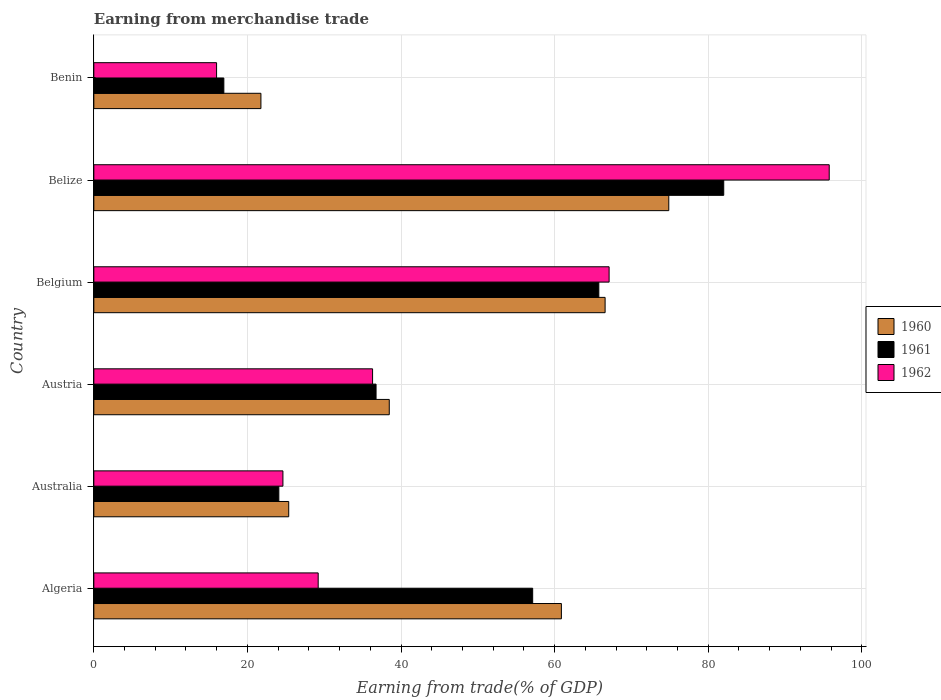How many different coloured bars are there?
Provide a succinct answer. 3. How many groups of bars are there?
Give a very brief answer. 6. Are the number of bars per tick equal to the number of legend labels?
Give a very brief answer. Yes. Are the number of bars on each tick of the Y-axis equal?
Keep it short and to the point. Yes. How many bars are there on the 4th tick from the bottom?
Your response must be concise. 3. What is the label of the 3rd group of bars from the top?
Your answer should be very brief. Belgium. What is the earnings from trade in 1960 in Algeria?
Ensure brevity in your answer.  60.88. Across all countries, what is the maximum earnings from trade in 1962?
Make the answer very short. 95.76. Across all countries, what is the minimum earnings from trade in 1960?
Offer a terse response. 21.76. In which country was the earnings from trade in 1960 maximum?
Keep it short and to the point. Belize. In which country was the earnings from trade in 1962 minimum?
Make the answer very short. Benin. What is the total earnings from trade in 1962 in the graph?
Your answer should be very brief. 268.98. What is the difference between the earnings from trade in 1962 in Australia and that in Benin?
Provide a succinct answer. 8.64. What is the difference between the earnings from trade in 1962 in Algeria and the earnings from trade in 1960 in Belgium?
Keep it short and to the point. -37.36. What is the average earnings from trade in 1962 per country?
Offer a terse response. 44.83. What is the difference between the earnings from trade in 1961 and earnings from trade in 1960 in Belize?
Offer a terse response. 7.15. What is the ratio of the earnings from trade in 1962 in Australia to that in Austria?
Give a very brief answer. 0.68. Is the difference between the earnings from trade in 1961 in Australia and Belgium greater than the difference between the earnings from trade in 1960 in Australia and Belgium?
Your response must be concise. No. What is the difference between the highest and the second highest earnings from trade in 1962?
Provide a succinct answer. 28.66. What is the difference between the highest and the lowest earnings from trade in 1962?
Your answer should be compact. 79.77. In how many countries, is the earnings from trade in 1960 greater than the average earnings from trade in 1960 taken over all countries?
Provide a succinct answer. 3. What does the 1st bar from the top in Austria represents?
Make the answer very short. 1962. Is it the case that in every country, the sum of the earnings from trade in 1961 and earnings from trade in 1962 is greater than the earnings from trade in 1960?
Provide a short and direct response. Yes. Are the values on the major ticks of X-axis written in scientific E-notation?
Ensure brevity in your answer.  No. How many legend labels are there?
Offer a very short reply. 3. What is the title of the graph?
Provide a short and direct response. Earning from merchandise trade. Does "2007" appear as one of the legend labels in the graph?
Give a very brief answer. No. What is the label or title of the X-axis?
Your answer should be very brief. Earning from trade(% of GDP). What is the Earning from trade(% of GDP) in 1960 in Algeria?
Your answer should be very brief. 60.88. What is the Earning from trade(% of GDP) of 1961 in Algeria?
Your answer should be compact. 57.14. What is the Earning from trade(% of GDP) in 1962 in Algeria?
Your answer should be very brief. 29.22. What is the Earning from trade(% of GDP) in 1960 in Australia?
Your answer should be very brief. 25.38. What is the Earning from trade(% of GDP) in 1961 in Australia?
Provide a succinct answer. 24.09. What is the Earning from trade(% of GDP) in 1962 in Australia?
Provide a succinct answer. 24.62. What is the Earning from trade(% of GDP) in 1960 in Austria?
Provide a succinct answer. 38.47. What is the Earning from trade(% of GDP) in 1961 in Austria?
Keep it short and to the point. 36.75. What is the Earning from trade(% of GDP) in 1962 in Austria?
Make the answer very short. 36.3. What is the Earning from trade(% of GDP) of 1960 in Belgium?
Offer a very short reply. 66.58. What is the Earning from trade(% of GDP) in 1961 in Belgium?
Keep it short and to the point. 65.76. What is the Earning from trade(% of GDP) of 1962 in Belgium?
Offer a terse response. 67.1. What is the Earning from trade(% of GDP) in 1960 in Belize?
Your answer should be compact. 74.87. What is the Earning from trade(% of GDP) of 1961 in Belize?
Provide a short and direct response. 82.02. What is the Earning from trade(% of GDP) in 1962 in Belize?
Provide a succinct answer. 95.76. What is the Earning from trade(% of GDP) in 1960 in Benin?
Your response must be concise. 21.76. What is the Earning from trade(% of GDP) in 1961 in Benin?
Provide a succinct answer. 16.93. What is the Earning from trade(% of GDP) in 1962 in Benin?
Keep it short and to the point. 15.99. Across all countries, what is the maximum Earning from trade(% of GDP) of 1960?
Keep it short and to the point. 74.87. Across all countries, what is the maximum Earning from trade(% of GDP) in 1961?
Make the answer very short. 82.02. Across all countries, what is the maximum Earning from trade(% of GDP) in 1962?
Keep it short and to the point. 95.76. Across all countries, what is the minimum Earning from trade(% of GDP) in 1960?
Give a very brief answer. 21.76. Across all countries, what is the minimum Earning from trade(% of GDP) in 1961?
Offer a very short reply. 16.93. Across all countries, what is the minimum Earning from trade(% of GDP) of 1962?
Your response must be concise. 15.99. What is the total Earning from trade(% of GDP) of 1960 in the graph?
Provide a succinct answer. 287.94. What is the total Earning from trade(% of GDP) of 1961 in the graph?
Provide a short and direct response. 282.7. What is the total Earning from trade(% of GDP) of 1962 in the graph?
Give a very brief answer. 268.98. What is the difference between the Earning from trade(% of GDP) in 1960 in Algeria and that in Australia?
Offer a terse response. 35.51. What is the difference between the Earning from trade(% of GDP) in 1961 in Algeria and that in Australia?
Provide a short and direct response. 33.05. What is the difference between the Earning from trade(% of GDP) in 1962 in Algeria and that in Australia?
Your answer should be very brief. 4.59. What is the difference between the Earning from trade(% of GDP) of 1960 in Algeria and that in Austria?
Offer a terse response. 22.41. What is the difference between the Earning from trade(% of GDP) in 1961 in Algeria and that in Austria?
Provide a short and direct response. 20.39. What is the difference between the Earning from trade(% of GDP) of 1962 in Algeria and that in Austria?
Your answer should be very brief. -7.08. What is the difference between the Earning from trade(% of GDP) in 1960 in Algeria and that in Belgium?
Make the answer very short. -5.69. What is the difference between the Earning from trade(% of GDP) of 1961 in Algeria and that in Belgium?
Make the answer very short. -8.61. What is the difference between the Earning from trade(% of GDP) of 1962 in Algeria and that in Belgium?
Your response must be concise. -37.88. What is the difference between the Earning from trade(% of GDP) of 1960 in Algeria and that in Belize?
Your answer should be very brief. -13.98. What is the difference between the Earning from trade(% of GDP) in 1961 in Algeria and that in Belize?
Provide a short and direct response. -24.88. What is the difference between the Earning from trade(% of GDP) of 1962 in Algeria and that in Belize?
Your answer should be compact. -66.54. What is the difference between the Earning from trade(% of GDP) of 1960 in Algeria and that in Benin?
Keep it short and to the point. 39.12. What is the difference between the Earning from trade(% of GDP) in 1961 in Algeria and that in Benin?
Give a very brief answer. 40.21. What is the difference between the Earning from trade(% of GDP) of 1962 in Algeria and that in Benin?
Provide a succinct answer. 13.23. What is the difference between the Earning from trade(% of GDP) of 1960 in Australia and that in Austria?
Provide a short and direct response. -13.09. What is the difference between the Earning from trade(% of GDP) of 1961 in Australia and that in Austria?
Offer a very short reply. -12.66. What is the difference between the Earning from trade(% of GDP) of 1962 in Australia and that in Austria?
Offer a terse response. -11.68. What is the difference between the Earning from trade(% of GDP) in 1960 in Australia and that in Belgium?
Keep it short and to the point. -41.2. What is the difference between the Earning from trade(% of GDP) of 1961 in Australia and that in Belgium?
Ensure brevity in your answer.  -41.67. What is the difference between the Earning from trade(% of GDP) in 1962 in Australia and that in Belgium?
Make the answer very short. -42.48. What is the difference between the Earning from trade(% of GDP) in 1960 in Australia and that in Belize?
Give a very brief answer. -49.49. What is the difference between the Earning from trade(% of GDP) of 1961 in Australia and that in Belize?
Your answer should be very brief. -57.93. What is the difference between the Earning from trade(% of GDP) of 1962 in Australia and that in Belize?
Provide a succinct answer. -71.14. What is the difference between the Earning from trade(% of GDP) of 1960 in Australia and that in Benin?
Your answer should be compact. 3.62. What is the difference between the Earning from trade(% of GDP) of 1961 in Australia and that in Benin?
Your answer should be compact. 7.16. What is the difference between the Earning from trade(% of GDP) in 1962 in Australia and that in Benin?
Ensure brevity in your answer.  8.64. What is the difference between the Earning from trade(% of GDP) of 1960 in Austria and that in Belgium?
Provide a succinct answer. -28.11. What is the difference between the Earning from trade(% of GDP) in 1961 in Austria and that in Belgium?
Keep it short and to the point. -29.01. What is the difference between the Earning from trade(% of GDP) in 1962 in Austria and that in Belgium?
Keep it short and to the point. -30.8. What is the difference between the Earning from trade(% of GDP) of 1960 in Austria and that in Belize?
Give a very brief answer. -36.4. What is the difference between the Earning from trade(% of GDP) of 1961 in Austria and that in Belize?
Keep it short and to the point. -45.27. What is the difference between the Earning from trade(% of GDP) of 1962 in Austria and that in Belize?
Give a very brief answer. -59.46. What is the difference between the Earning from trade(% of GDP) of 1960 in Austria and that in Benin?
Offer a very short reply. 16.71. What is the difference between the Earning from trade(% of GDP) in 1961 in Austria and that in Benin?
Keep it short and to the point. 19.82. What is the difference between the Earning from trade(% of GDP) of 1962 in Austria and that in Benin?
Provide a succinct answer. 20.31. What is the difference between the Earning from trade(% of GDP) in 1960 in Belgium and that in Belize?
Offer a terse response. -8.29. What is the difference between the Earning from trade(% of GDP) in 1961 in Belgium and that in Belize?
Offer a terse response. -16.27. What is the difference between the Earning from trade(% of GDP) in 1962 in Belgium and that in Belize?
Make the answer very short. -28.66. What is the difference between the Earning from trade(% of GDP) in 1960 in Belgium and that in Benin?
Your answer should be very brief. 44.82. What is the difference between the Earning from trade(% of GDP) in 1961 in Belgium and that in Benin?
Ensure brevity in your answer.  48.83. What is the difference between the Earning from trade(% of GDP) in 1962 in Belgium and that in Benin?
Your answer should be very brief. 51.11. What is the difference between the Earning from trade(% of GDP) in 1960 in Belize and that in Benin?
Keep it short and to the point. 53.11. What is the difference between the Earning from trade(% of GDP) of 1961 in Belize and that in Benin?
Provide a succinct answer. 65.09. What is the difference between the Earning from trade(% of GDP) in 1962 in Belize and that in Benin?
Your response must be concise. 79.77. What is the difference between the Earning from trade(% of GDP) in 1960 in Algeria and the Earning from trade(% of GDP) in 1961 in Australia?
Provide a succinct answer. 36.79. What is the difference between the Earning from trade(% of GDP) of 1960 in Algeria and the Earning from trade(% of GDP) of 1962 in Australia?
Your answer should be very brief. 36.26. What is the difference between the Earning from trade(% of GDP) in 1961 in Algeria and the Earning from trade(% of GDP) in 1962 in Australia?
Make the answer very short. 32.52. What is the difference between the Earning from trade(% of GDP) of 1960 in Algeria and the Earning from trade(% of GDP) of 1961 in Austria?
Provide a short and direct response. 24.13. What is the difference between the Earning from trade(% of GDP) in 1960 in Algeria and the Earning from trade(% of GDP) in 1962 in Austria?
Keep it short and to the point. 24.59. What is the difference between the Earning from trade(% of GDP) in 1961 in Algeria and the Earning from trade(% of GDP) in 1962 in Austria?
Give a very brief answer. 20.85. What is the difference between the Earning from trade(% of GDP) in 1960 in Algeria and the Earning from trade(% of GDP) in 1961 in Belgium?
Ensure brevity in your answer.  -4.87. What is the difference between the Earning from trade(% of GDP) of 1960 in Algeria and the Earning from trade(% of GDP) of 1962 in Belgium?
Your answer should be compact. -6.21. What is the difference between the Earning from trade(% of GDP) in 1961 in Algeria and the Earning from trade(% of GDP) in 1962 in Belgium?
Your answer should be compact. -9.96. What is the difference between the Earning from trade(% of GDP) in 1960 in Algeria and the Earning from trade(% of GDP) in 1961 in Belize?
Give a very brief answer. -21.14. What is the difference between the Earning from trade(% of GDP) of 1960 in Algeria and the Earning from trade(% of GDP) of 1962 in Belize?
Keep it short and to the point. -34.88. What is the difference between the Earning from trade(% of GDP) of 1961 in Algeria and the Earning from trade(% of GDP) of 1962 in Belize?
Your response must be concise. -38.62. What is the difference between the Earning from trade(% of GDP) in 1960 in Algeria and the Earning from trade(% of GDP) in 1961 in Benin?
Give a very brief answer. 43.95. What is the difference between the Earning from trade(% of GDP) of 1960 in Algeria and the Earning from trade(% of GDP) of 1962 in Benin?
Your answer should be very brief. 44.9. What is the difference between the Earning from trade(% of GDP) of 1961 in Algeria and the Earning from trade(% of GDP) of 1962 in Benin?
Offer a very short reply. 41.16. What is the difference between the Earning from trade(% of GDP) of 1960 in Australia and the Earning from trade(% of GDP) of 1961 in Austria?
Your answer should be very brief. -11.37. What is the difference between the Earning from trade(% of GDP) in 1960 in Australia and the Earning from trade(% of GDP) in 1962 in Austria?
Make the answer very short. -10.92. What is the difference between the Earning from trade(% of GDP) in 1961 in Australia and the Earning from trade(% of GDP) in 1962 in Austria?
Give a very brief answer. -12.21. What is the difference between the Earning from trade(% of GDP) of 1960 in Australia and the Earning from trade(% of GDP) of 1961 in Belgium?
Offer a terse response. -40.38. What is the difference between the Earning from trade(% of GDP) of 1960 in Australia and the Earning from trade(% of GDP) of 1962 in Belgium?
Keep it short and to the point. -41.72. What is the difference between the Earning from trade(% of GDP) of 1961 in Australia and the Earning from trade(% of GDP) of 1962 in Belgium?
Give a very brief answer. -43.01. What is the difference between the Earning from trade(% of GDP) in 1960 in Australia and the Earning from trade(% of GDP) in 1961 in Belize?
Provide a succinct answer. -56.65. What is the difference between the Earning from trade(% of GDP) in 1960 in Australia and the Earning from trade(% of GDP) in 1962 in Belize?
Make the answer very short. -70.38. What is the difference between the Earning from trade(% of GDP) in 1961 in Australia and the Earning from trade(% of GDP) in 1962 in Belize?
Your response must be concise. -71.67. What is the difference between the Earning from trade(% of GDP) of 1960 in Australia and the Earning from trade(% of GDP) of 1961 in Benin?
Your answer should be very brief. 8.45. What is the difference between the Earning from trade(% of GDP) of 1960 in Australia and the Earning from trade(% of GDP) of 1962 in Benin?
Offer a terse response. 9.39. What is the difference between the Earning from trade(% of GDP) of 1961 in Australia and the Earning from trade(% of GDP) of 1962 in Benin?
Keep it short and to the point. 8.11. What is the difference between the Earning from trade(% of GDP) of 1960 in Austria and the Earning from trade(% of GDP) of 1961 in Belgium?
Your answer should be very brief. -27.29. What is the difference between the Earning from trade(% of GDP) of 1960 in Austria and the Earning from trade(% of GDP) of 1962 in Belgium?
Offer a terse response. -28.63. What is the difference between the Earning from trade(% of GDP) in 1961 in Austria and the Earning from trade(% of GDP) in 1962 in Belgium?
Keep it short and to the point. -30.35. What is the difference between the Earning from trade(% of GDP) of 1960 in Austria and the Earning from trade(% of GDP) of 1961 in Belize?
Your response must be concise. -43.55. What is the difference between the Earning from trade(% of GDP) of 1960 in Austria and the Earning from trade(% of GDP) of 1962 in Belize?
Offer a terse response. -57.29. What is the difference between the Earning from trade(% of GDP) in 1961 in Austria and the Earning from trade(% of GDP) in 1962 in Belize?
Ensure brevity in your answer.  -59.01. What is the difference between the Earning from trade(% of GDP) of 1960 in Austria and the Earning from trade(% of GDP) of 1961 in Benin?
Your response must be concise. 21.54. What is the difference between the Earning from trade(% of GDP) in 1960 in Austria and the Earning from trade(% of GDP) in 1962 in Benin?
Provide a succinct answer. 22.48. What is the difference between the Earning from trade(% of GDP) in 1961 in Austria and the Earning from trade(% of GDP) in 1962 in Benin?
Offer a terse response. 20.77. What is the difference between the Earning from trade(% of GDP) of 1960 in Belgium and the Earning from trade(% of GDP) of 1961 in Belize?
Provide a succinct answer. -15.45. What is the difference between the Earning from trade(% of GDP) in 1960 in Belgium and the Earning from trade(% of GDP) in 1962 in Belize?
Your response must be concise. -29.18. What is the difference between the Earning from trade(% of GDP) of 1961 in Belgium and the Earning from trade(% of GDP) of 1962 in Belize?
Give a very brief answer. -30. What is the difference between the Earning from trade(% of GDP) in 1960 in Belgium and the Earning from trade(% of GDP) in 1961 in Benin?
Give a very brief answer. 49.65. What is the difference between the Earning from trade(% of GDP) of 1960 in Belgium and the Earning from trade(% of GDP) of 1962 in Benin?
Ensure brevity in your answer.  50.59. What is the difference between the Earning from trade(% of GDP) in 1961 in Belgium and the Earning from trade(% of GDP) in 1962 in Benin?
Make the answer very short. 49.77. What is the difference between the Earning from trade(% of GDP) of 1960 in Belize and the Earning from trade(% of GDP) of 1961 in Benin?
Provide a short and direct response. 57.94. What is the difference between the Earning from trade(% of GDP) of 1960 in Belize and the Earning from trade(% of GDP) of 1962 in Benin?
Give a very brief answer. 58.88. What is the difference between the Earning from trade(% of GDP) of 1961 in Belize and the Earning from trade(% of GDP) of 1962 in Benin?
Provide a succinct answer. 66.04. What is the average Earning from trade(% of GDP) of 1960 per country?
Provide a succinct answer. 47.99. What is the average Earning from trade(% of GDP) of 1961 per country?
Provide a succinct answer. 47.12. What is the average Earning from trade(% of GDP) in 1962 per country?
Provide a succinct answer. 44.83. What is the difference between the Earning from trade(% of GDP) of 1960 and Earning from trade(% of GDP) of 1961 in Algeria?
Give a very brief answer. 3.74. What is the difference between the Earning from trade(% of GDP) in 1960 and Earning from trade(% of GDP) in 1962 in Algeria?
Keep it short and to the point. 31.67. What is the difference between the Earning from trade(% of GDP) in 1961 and Earning from trade(% of GDP) in 1962 in Algeria?
Your response must be concise. 27.93. What is the difference between the Earning from trade(% of GDP) of 1960 and Earning from trade(% of GDP) of 1961 in Australia?
Offer a very short reply. 1.29. What is the difference between the Earning from trade(% of GDP) in 1960 and Earning from trade(% of GDP) in 1962 in Australia?
Provide a succinct answer. 0.76. What is the difference between the Earning from trade(% of GDP) of 1961 and Earning from trade(% of GDP) of 1962 in Australia?
Provide a short and direct response. -0.53. What is the difference between the Earning from trade(% of GDP) of 1960 and Earning from trade(% of GDP) of 1961 in Austria?
Offer a terse response. 1.72. What is the difference between the Earning from trade(% of GDP) in 1960 and Earning from trade(% of GDP) in 1962 in Austria?
Make the answer very short. 2.17. What is the difference between the Earning from trade(% of GDP) of 1961 and Earning from trade(% of GDP) of 1962 in Austria?
Keep it short and to the point. 0.45. What is the difference between the Earning from trade(% of GDP) in 1960 and Earning from trade(% of GDP) in 1961 in Belgium?
Give a very brief answer. 0.82. What is the difference between the Earning from trade(% of GDP) of 1960 and Earning from trade(% of GDP) of 1962 in Belgium?
Offer a terse response. -0.52. What is the difference between the Earning from trade(% of GDP) in 1961 and Earning from trade(% of GDP) in 1962 in Belgium?
Your answer should be very brief. -1.34. What is the difference between the Earning from trade(% of GDP) of 1960 and Earning from trade(% of GDP) of 1961 in Belize?
Keep it short and to the point. -7.16. What is the difference between the Earning from trade(% of GDP) of 1960 and Earning from trade(% of GDP) of 1962 in Belize?
Offer a very short reply. -20.89. What is the difference between the Earning from trade(% of GDP) of 1961 and Earning from trade(% of GDP) of 1962 in Belize?
Offer a very short reply. -13.74. What is the difference between the Earning from trade(% of GDP) in 1960 and Earning from trade(% of GDP) in 1961 in Benin?
Keep it short and to the point. 4.83. What is the difference between the Earning from trade(% of GDP) of 1960 and Earning from trade(% of GDP) of 1962 in Benin?
Ensure brevity in your answer.  5.77. What is the difference between the Earning from trade(% of GDP) of 1961 and Earning from trade(% of GDP) of 1962 in Benin?
Offer a very short reply. 0.95. What is the ratio of the Earning from trade(% of GDP) of 1960 in Algeria to that in Australia?
Ensure brevity in your answer.  2.4. What is the ratio of the Earning from trade(% of GDP) in 1961 in Algeria to that in Australia?
Keep it short and to the point. 2.37. What is the ratio of the Earning from trade(% of GDP) in 1962 in Algeria to that in Australia?
Offer a very short reply. 1.19. What is the ratio of the Earning from trade(% of GDP) of 1960 in Algeria to that in Austria?
Keep it short and to the point. 1.58. What is the ratio of the Earning from trade(% of GDP) of 1961 in Algeria to that in Austria?
Provide a succinct answer. 1.55. What is the ratio of the Earning from trade(% of GDP) of 1962 in Algeria to that in Austria?
Your response must be concise. 0.8. What is the ratio of the Earning from trade(% of GDP) of 1960 in Algeria to that in Belgium?
Provide a short and direct response. 0.91. What is the ratio of the Earning from trade(% of GDP) of 1961 in Algeria to that in Belgium?
Give a very brief answer. 0.87. What is the ratio of the Earning from trade(% of GDP) in 1962 in Algeria to that in Belgium?
Your response must be concise. 0.44. What is the ratio of the Earning from trade(% of GDP) in 1960 in Algeria to that in Belize?
Give a very brief answer. 0.81. What is the ratio of the Earning from trade(% of GDP) of 1961 in Algeria to that in Belize?
Offer a terse response. 0.7. What is the ratio of the Earning from trade(% of GDP) of 1962 in Algeria to that in Belize?
Offer a terse response. 0.31. What is the ratio of the Earning from trade(% of GDP) of 1960 in Algeria to that in Benin?
Offer a very short reply. 2.8. What is the ratio of the Earning from trade(% of GDP) of 1961 in Algeria to that in Benin?
Your answer should be compact. 3.38. What is the ratio of the Earning from trade(% of GDP) of 1962 in Algeria to that in Benin?
Make the answer very short. 1.83. What is the ratio of the Earning from trade(% of GDP) of 1960 in Australia to that in Austria?
Your response must be concise. 0.66. What is the ratio of the Earning from trade(% of GDP) of 1961 in Australia to that in Austria?
Your response must be concise. 0.66. What is the ratio of the Earning from trade(% of GDP) of 1962 in Australia to that in Austria?
Offer a very short reply. 0.68. What is the ratio of the Earning from trade(% of GDP) of 1960 in Australia to that in Belgium?
Give a very brief answer. 0.38. What is the ratio of the Earning from trade(% of GDP) of 1961 in Australia to that in Belgium?
Offer a terse response. 0.37. What is the ratio of the Earning from trade(% of GDP) in 1962 in Australia to that in Belgium?
Your answer should be very brief. 0.37. What is the ratio of the Earning from trade(% of GDP) of 1960 in Australia to that in Belize?
Your response must be concise. 0.34. What is the ratio of the Earning from trade(% of GDP) in 1961 in Australia to that in Belize?
Provide a short and direct response. 0.29. What is the ratio of the Earning from trade(% of GDP) in 1962 in Australia to that in Belize?
Ensure brevity in your answer.  0.26. What is the ratio of the Earning from trade(% of GDP) in 1960 in Australia to that in Benin?
Your response must be concise. 1.17. What is the ratio of the Earning from trade(% of GDP) in 1961 in Australia to that in Benin?
Provide a succinct answer. 1.42. What is the ratio of the Earning from trade(% of GDP) in 1962 in Australia to that in Benin?
Offer a very short reply. 1.54. What is the ratio of the Earning from trade(% of GDP) of 1960 in Austria to that in Belgium?
Your response must be concise. 0.58. What is the ratio of the Earning from trade(% of GDP) of 1961 in Austria to that in Belgium?
Keep it short and to the point. 0.56. What is the ratio of the Earning from trade(% of GDP) in 1962 in Austria to that in Belgium?
Your answer should be compact. 0.54. What is the ratio of the Earning from trade(% of GDP) of 1960 in Austria to that in Belize?
Make the answer very short. 0.51. What is the ratio of the Earning from trade(% of GDP) of 1961 in Austria to that in Belize?
Provide a succinct answer. 0.45. What is the ratio of the Earning from trade(% of GDP) in 1962 in Austria to that in Belize?
Give a very brief answer. 0.38. What is the ratio of the Earning from trade(% of GDP) in 1960 in Austria to that in Benin?
Give a very brief answer. 1.77. What is the ratio of the Earning from trade(% of GDP) of 1961 in Austria to that in Benin?
Offer a very short reply. 2.17. What is the ratio of the Earning from trade(% of GDP) of 1962 in Austria to that in Benin?
Provide a short and direct response. 2.27. What is the ratio of the Earning from trade(% of GDP) of 1960 in Belgium to that in Belize?
Offer a very short reply. 0.89. What is the ratio of the Earning from trade(% of GDP) of 1961 in Belgium to that in Belize?
Make the answer very short. 0.8. What is the ratio of the Earning from trade(% of GDP) of 1962 in Belgium to that in Belize?
Keep it short and to the point. 0.7. What is the ratio of the Earning from trade(% of GDP) in 1960 in Belgium to that in Benin?
Your response must be concise. 3.06. What is the ratio of the Earning from trade(% of GDP) in 1961 in Belgium to that in Benin?
Your answer should be very brief. 3.88. What is the ratio of the Earning from trade(% of GDP) of 1962 in Belgium to that in Benin?
Your answer should be compact. 4.2. What is the ratio of the Earning from trade(% of GDP) in 1960 in Belize to that in Benin?
Make the answer very short. 3.44. What is the ratio of the Earning from trade(% of GDP) of 1961 in Belize to that in Benin?
Offer a terse response. 4.84. What is the ratio of the Earning from trade(% of GDP) of 1962 in Belize to that in Benin?
Offer a terse response. 5.99. What is the difference between the highest and the second highest Earning from trade(% of GDP) in 1960?
Offer a very short reply. 8.29. What is the difference between the highest and the second highest Earning from trade(% of GDP) of 1961?
Your answer should be compact. 16.27. What is the difference between the highest and the second highest Earning from trade(% of GDP) in 1962?
Offer a very short reply. 28.66. What is the difference between the highest and the lowest Earning from trade(% of GDP) in 1960?
Provide a succinct answer. 53.11. What is the difference between the highest and the lowest Earning from trade(% of GDP) of 1961?
Keep it short and to the point. 65.09. What is the difference between the highest and the lowest Earning from trade(% of GDP) in 1962?
Give a very brief answer. 79.77. 